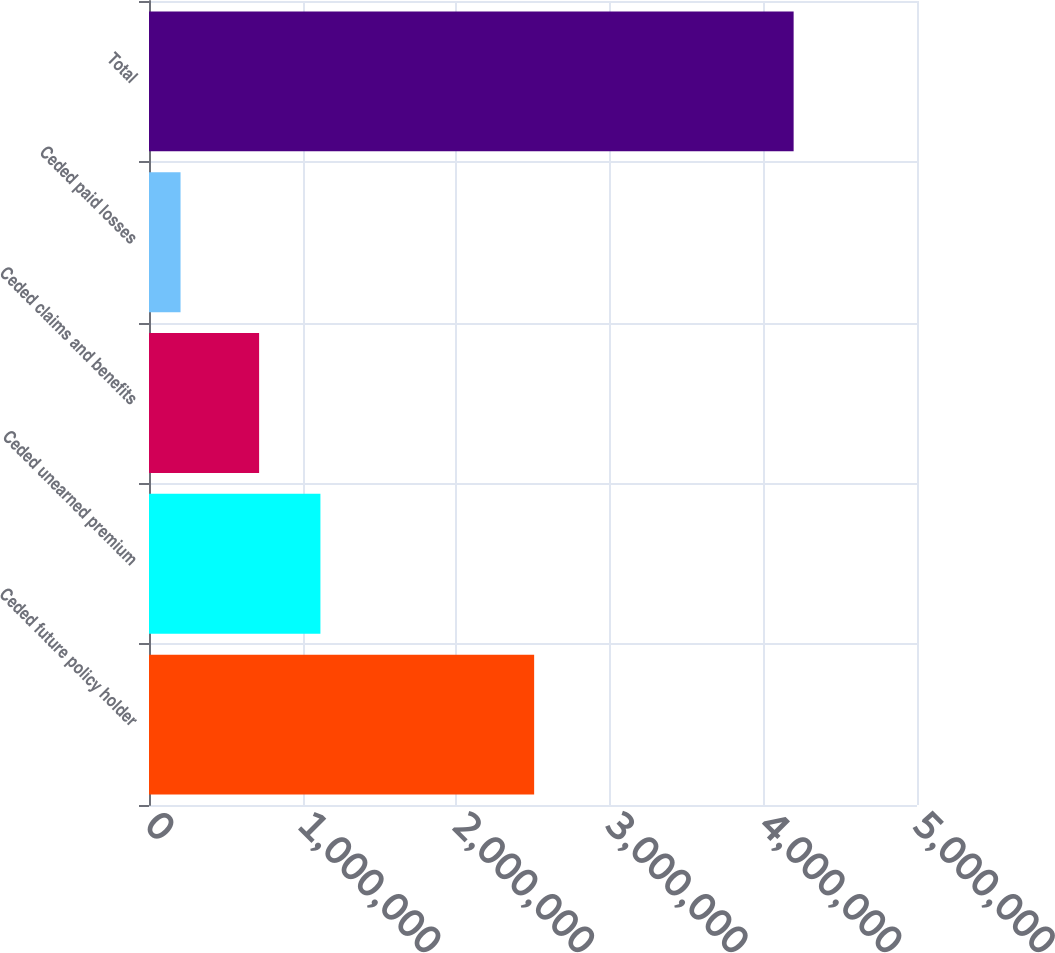Convert chart. <chart><loc_0><loc_0><loc_500><loc_500><bar_chart><fcel>Ceded future policy holder<fcel>Ceded unearned premium<fcel>Ceded claims and benefits<fcel>Ceded paid losses<fcel>Total<nl><fcel>2.50745e+06<fcel>1.11602e+06<fcel>716871<fcel>205365<fcel>4.19681e+06<nl></chart> 